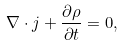Convert formula to latex. <formula><loc_0><loc_0><loc_500><loc_500>\nabla \cdot j + \frac { \partial \rho } { \partial t } = 0 ,</formula> 